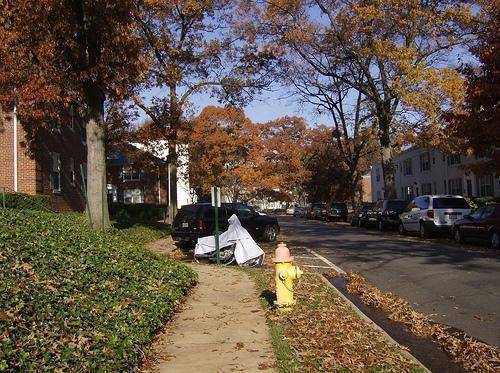What is the most likely reason that the bike is covered where it is?
Pick the correct solution from the four options below to address the question.
Options: Legal, protection, style, camouflage. Protection. 